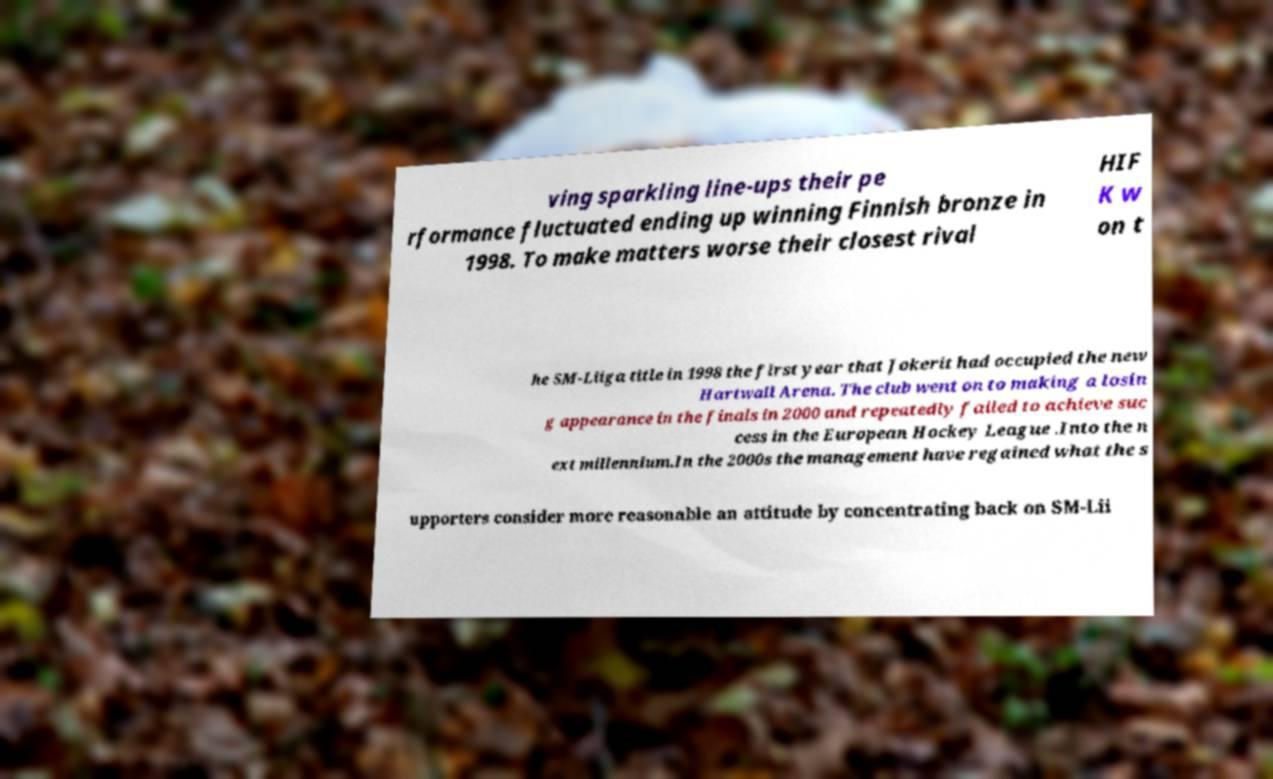For documentation purposes, I need the text within this image transcribed. Could you provide that? ving sparkling line-ups their pe rformance fluctuated ending up winning Finnish bronze in 1998. To make matters worse their closest rival HIF K w on t he SM-Liiga title in 1998 the first year that Jokerit had occupied the new Hartwall Arena. The club went on to making a losin g appearance in the finals in 2000 and repeatedly failed to achieve suc cess in the European Hockey League .Into the n ext millennium.In the 2000s the management have regained what the s upporters consider more reasonable an attitude by concentrating back on SM-Lii 